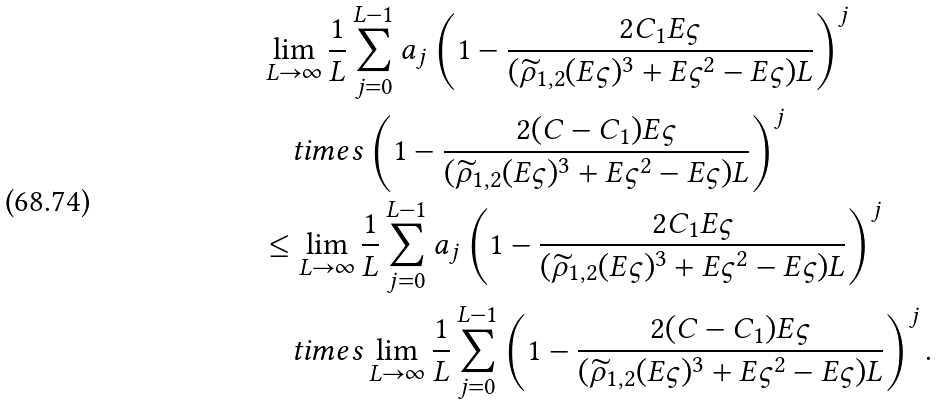<formula> <loc_0><loc_0><loc_500><loc_500>& \lim _ { L \to \infty } \frac { 1 } { L } \sum _ { j = 0 } ^ { L - 1 } a _ { j } \left ( 1 - \frac { 2 C _ { 1 } E \varsigma } { ( \widetilde { \rho } _ { 1 , 2 } ( E \varsigma ) ^ { 3 } + E \varsigma ^ { 2 } - E \varsigma ) L } \right ) ^ { j } \\ & \quad t i m e s \left ( 1 - \frac { 2 ( C - C _ { 1 } ) E \varsigma } { ( \widetilde { \rho } _ { 1 , 2 } ( E \varsigma ) ^ { 3 } + E \varsigma ^ { 2 } - E \varsigma ) L } \right ) ^ { j } \\ & \leq \lim _ { L \to \infty } \frac { 1 } { L } \sum _ { j = 0 } ^ { L - 1 } a _ { j } \left ( 1 - \frac { 2 C _ { 1 } E \varsigma } { ( \widetilde { \rho } _ { 1 , 2 } ( E \varsigma ) ^ { 3 } + E \varsigma ^ { 2 } - E \varsigma ) L } \right ) ^ { j } \\ & \quad t i m e s \lim _ { L \to \infty } \frac { 1 } { L } \sum _ { j = 0 } ^ { L - 1 } \left ( 1 - \frac { 2 ( C - C _ { 1 } ) E \varsigma } { ( \widetilde { \rho } _ { 1 , 2 } ( E \varsigma ) ^ { 3 } + E \varsigma ^ { 2 } - E \varsigma ) L } \right ) ^ { j } .</formula> 